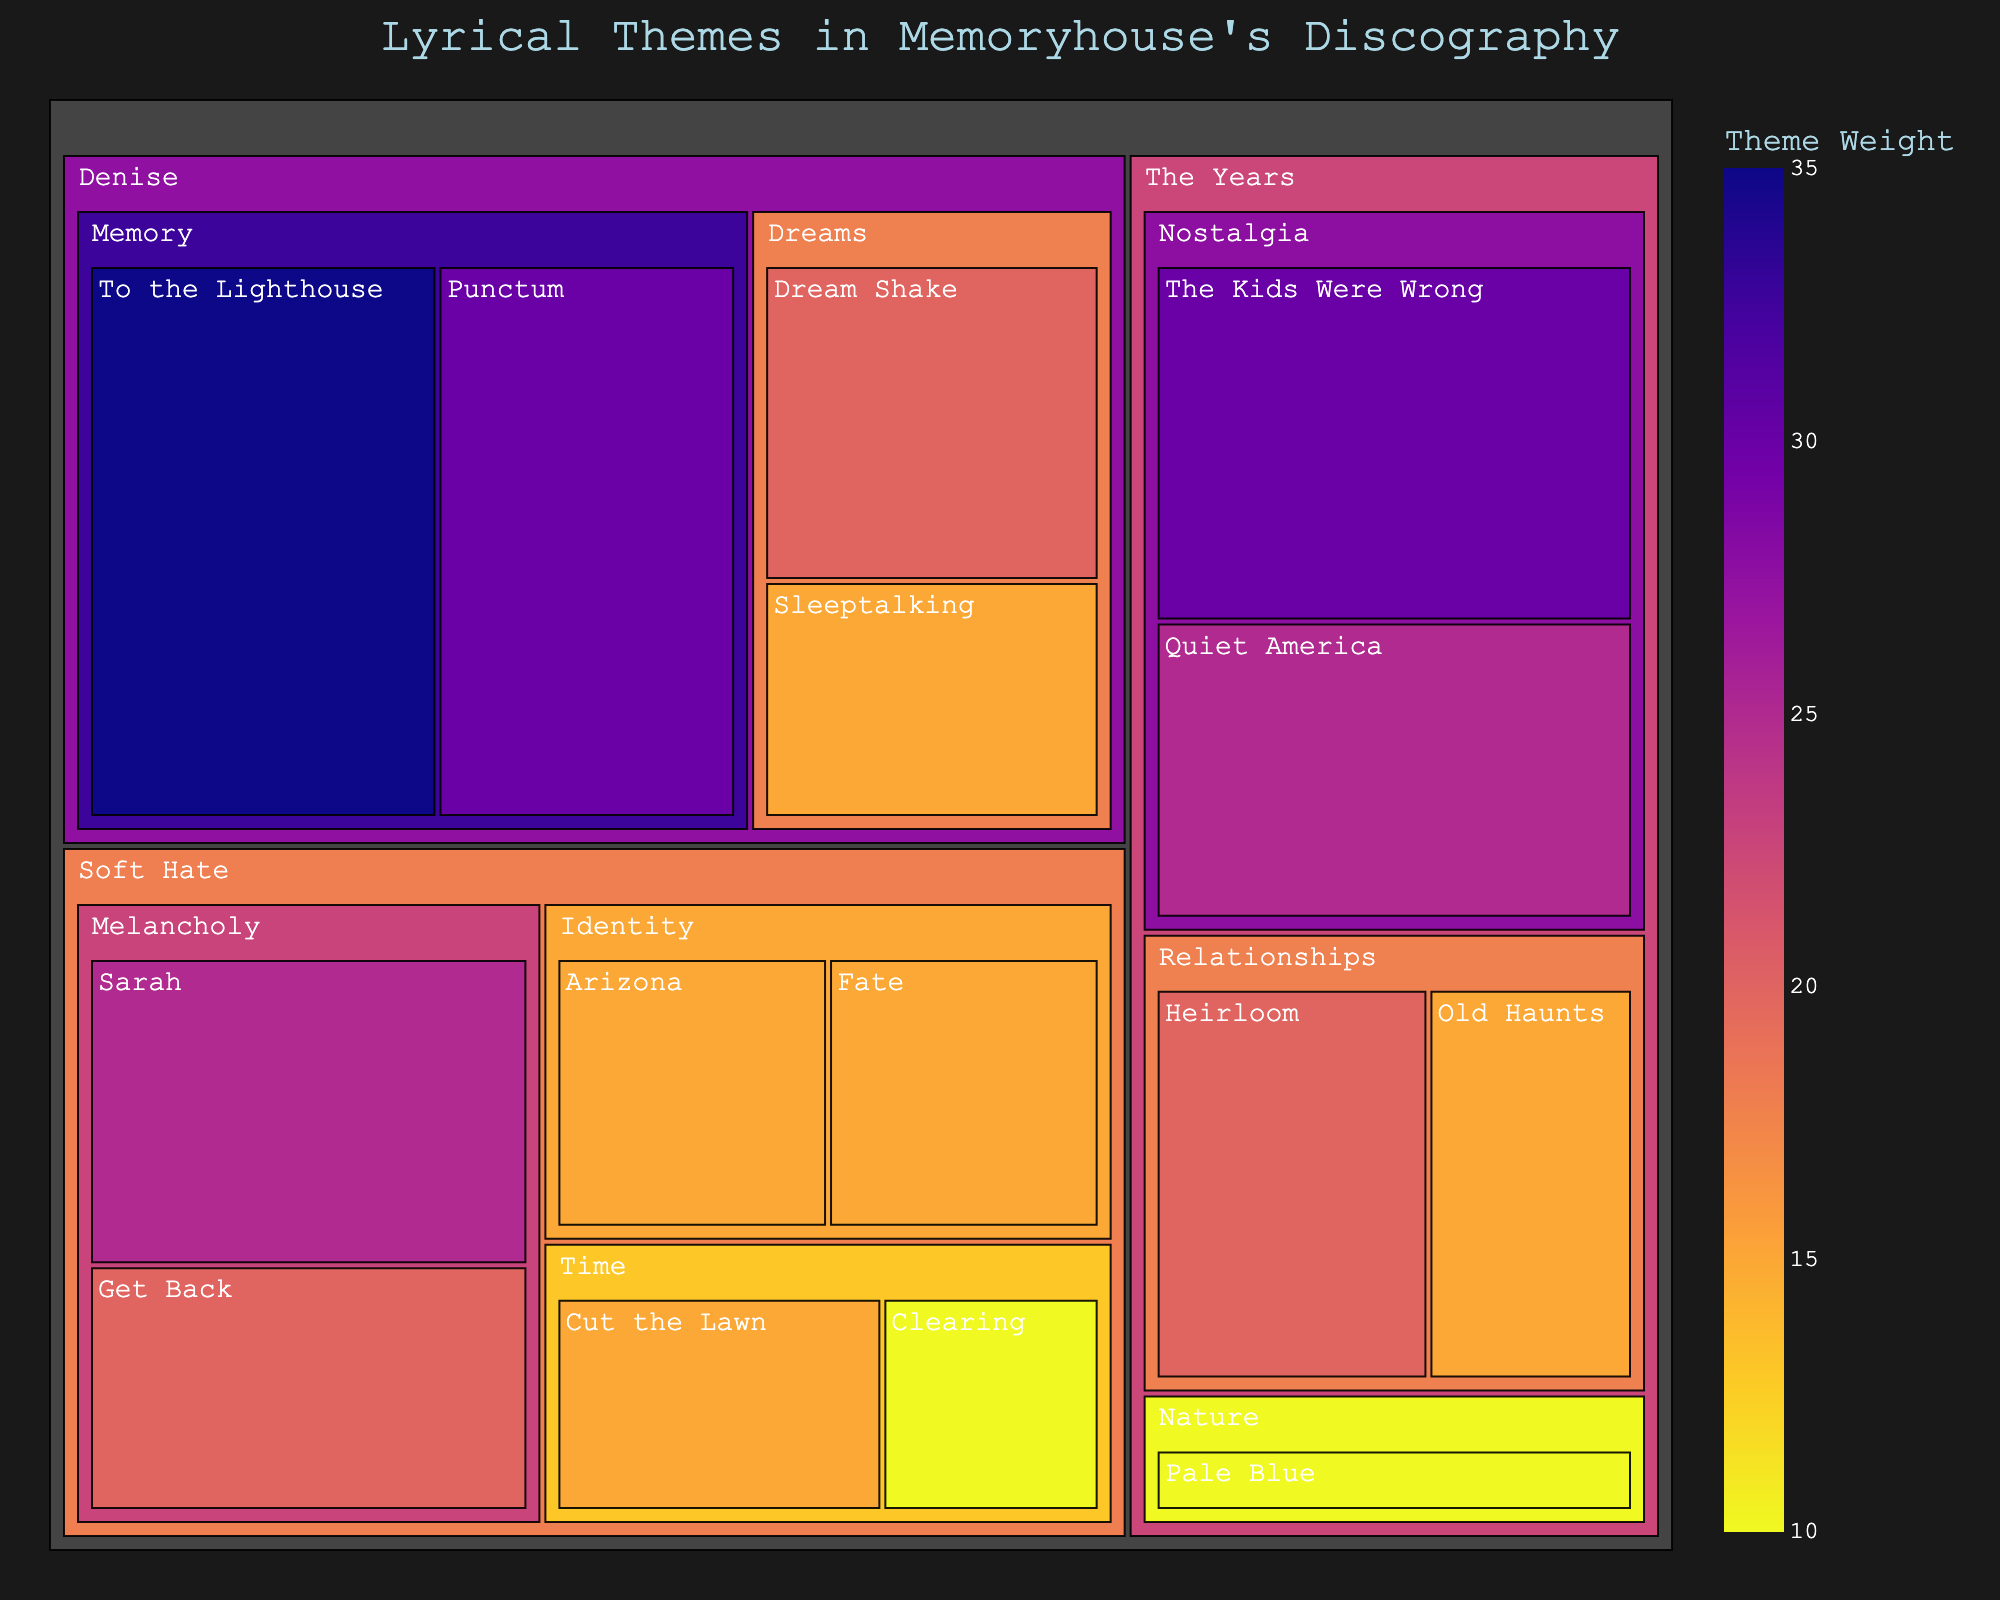what is the title of the plot? The title is usually found at the top of the treemap and it explains the subject of the figure. In this case, it describes the thematic distribution in Memoryhouse's songs.
Answer: Lyrical Themes in Memoryhouse's Discography What are the themes found in the album "The Years"? The themes are organized hierarchically under the album in the treemap. By looking under "The Years", we can see the different themes associated with it.
Answer: Nostalgia, Relationships, Nature Which song has the highest weight in the album "Denise"? In the album "Denise", the weight of each song is color-coded and labeled. By comparing the weights, we can identify the heaviest one.
Answer: To the Lighthouse How does the theme of "Memory" in the album "Denise" compare to the theme of "Nostalgia" in "The Years" in terms of total weight? Calculate the sum of the weights of songs under each theme within their respective albums and then compare the results. For "Denise", Memory: 35+30=65. For "The Years", Nostalgia: 30+25=55.
Answer: Memory in "Denise" has a higher total weight (65 vs 55) Which album has the most variety of themes? Count the number of different themes listed under each album. The album with the most distinct themes is the answer. "The Years" has three themes, "Denise" has two, and "Soft Hate" has three.
Answer: The Years What is the average weight of songs in the theme "Dreams" in the album "Denise"? Add the weights of the songs under the "Dreams" theme and divide by the number of songs. Under "Dreams": (20 + 15) / 2 = 35 / 2 = 17.5
Answer: 17.5 Which theme appears in the album "Soft Hate" with the least total weight and what is that weight? Sum the weights of the songs under each theme in "Soft Hate" and find the smallest total. Time: 15 + 10 = 25. Identity: 15 + 15 = 30. Melancholy: 25 + 20 = 45. The least total weight is for the theme "Time".
Answer: Time, 25 How many songs from the album "The Years" fall under the theme of "Relationships"? Count the number of songs listed under the theme "Relationships" in "The Years". There are two songs: "Heirloom" and "Old Haunts".
Answer: two 